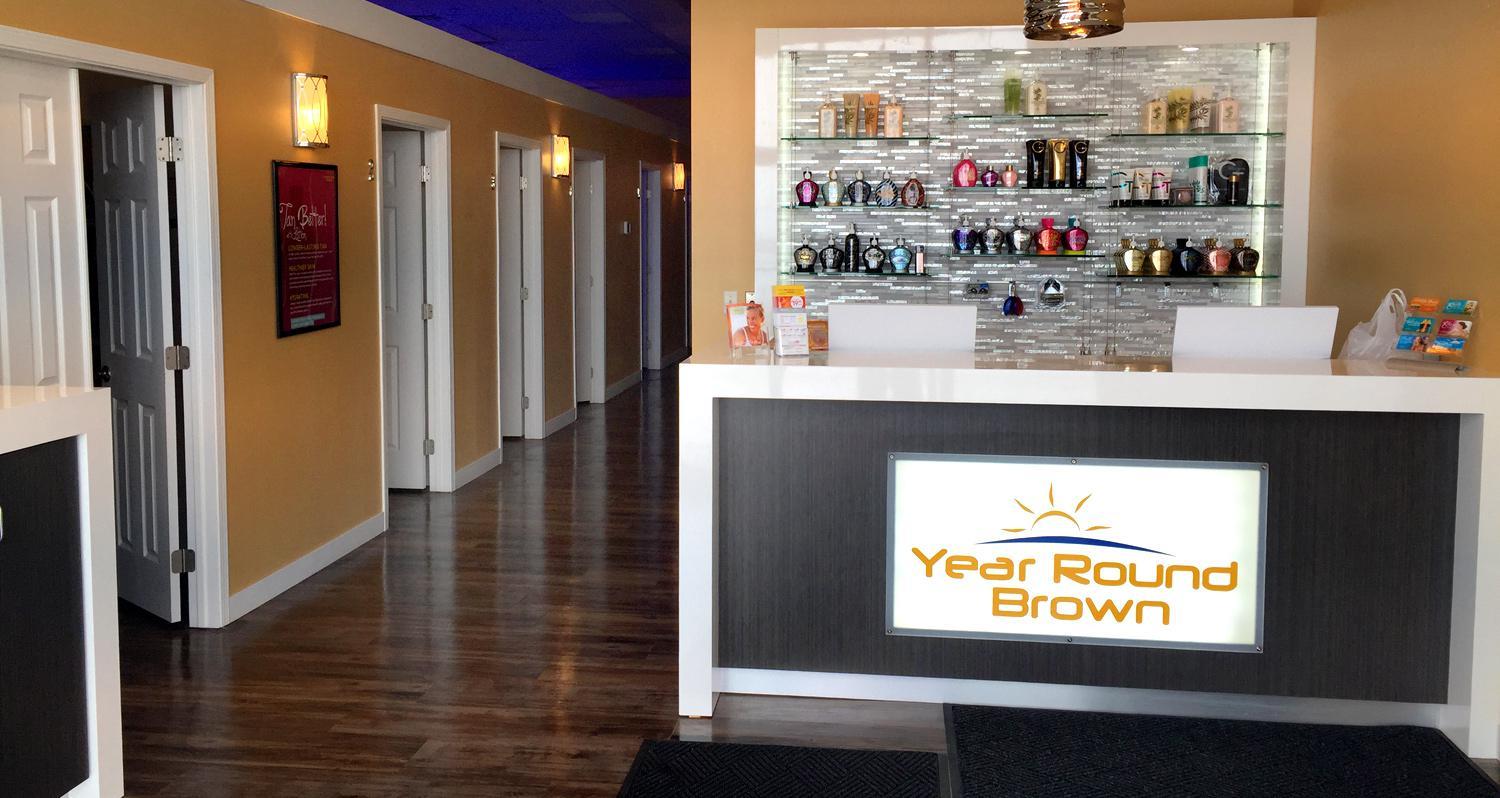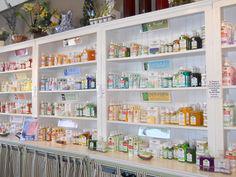The first image is the image on the left, the second image is the image on the right. Examine the images to the left and right. Is the description "Below the salable items, you'll notice the words, """"Tanning Shop""""" accurate? Answer yes or no. No. The first image is the image on the left, the second image is the image on the right. Examine the images to the left and right. Is the description "Many different kinds of tanning lotion hang behind a booth that reads Tanning Shop." accurate? Answer yes or no. No. 